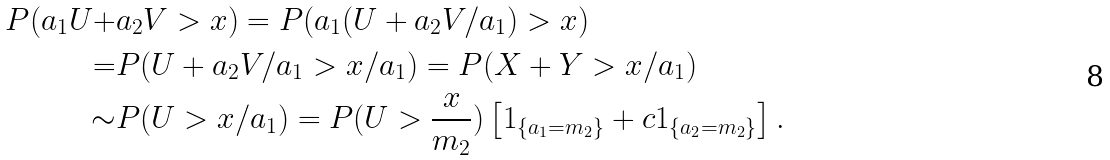<formula> <loc_0><loc_0><loc_500><loc_500>P ( a _ { 1 } U + & a _ { 2 } V > x ) = P ( a _ { 1 } ( U + a _ { 2 } V / a _ { 1 } ) > x ) \\ = & P ( U + a _ { 2 } V / a _ { 1 } > x / a _ { 1 } ) = P ( X + Y > x / a _ { 1 } ) \\ \sim & P ( U > x / a _ { 1 } ) = P ( U > \frac { x } { m _ { 2 } } ) \left [ 1 _ { \{ a _ { 1 } = m _ { 2 } \} } + c 1 _ { \{ a _ { 2 } = m _ { 2 } \} } \right ] .</formula> 